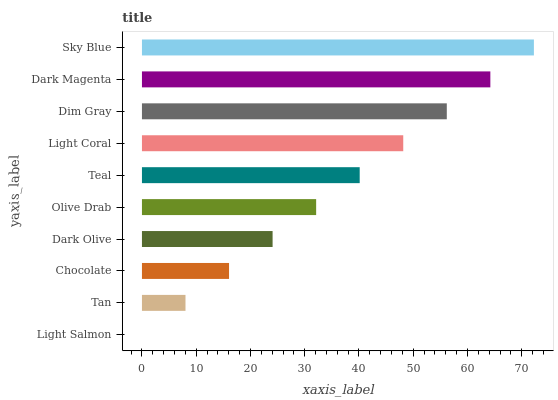Is Light Salmon the minimum?
Answer yes or no. Yes. Is Sky Blue the maximum?
Answer yes or no. Yes. Is Tan the minimum?
Answer yes or no. No. Is Tan the maximum?
Answer yes or no. No. Is Tan greater than Light Salmon?
Answer yes or no. Yes. Is Light Salmon less than Tan?
Answer yes or no. Yes. Is Light Salmon greater than Tan?
Answer yes or no. No. Is Tan less than Light Salmon?
Answer yes or no. No. Is Teal the high median?
Answer yes or no. Yes. Is Olive Drab the low median?
Answer yes or no. Yes. Is Dim Gray the high median?
Answer yes or no. No. Is Dim Gray the low median?
Answer yes or no. No. 